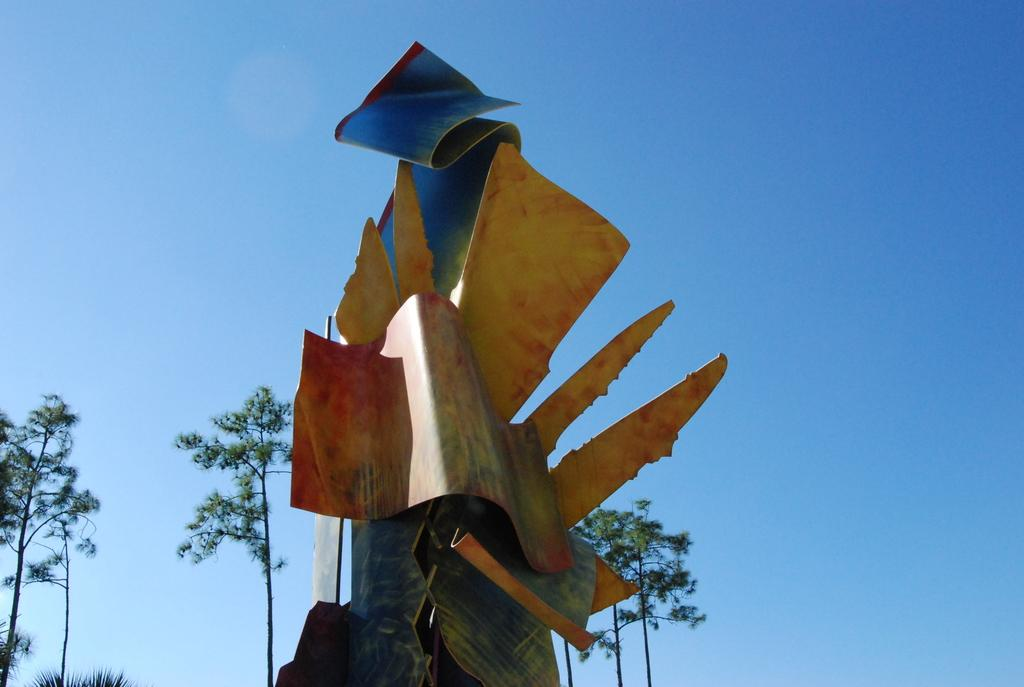Where was the image taken? The image was taken outdoors. What can be seen in the background of the image? There is a sky and trees visible in the background of the image. What is the main subject in the middle of the image? There is an architectural structure in the middle of the image. What type of powder is being used to twist the zephyr in the image? There is no powder or zephyr present in the image. 